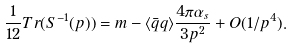<formula> <loc_0><loc_0><loc_500><loc_500>\frac { 1 } { 1 2 } T r ( S ^ { - 1 } ( p ) ) = m - \langle \bar { q } q \rangle \frac { 4 \pi \alpha _ { s } } { 3 p ^ { 2 } } + O ( 1 / p ^ { 4 } ) .</formula> 